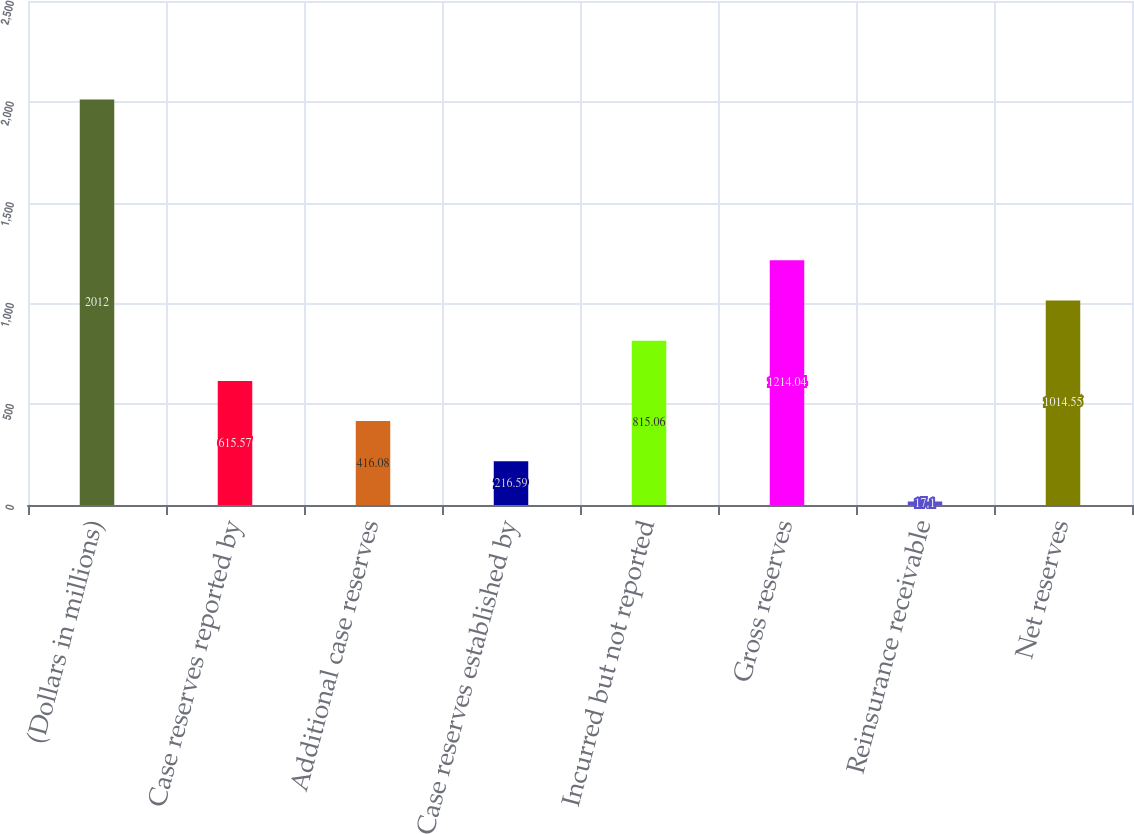Convert chart. <chart><loc_0><loc_0><loc_500><loc_500><bar_chart><fcel>(Dollars in millions)<fcel>Case reserves reported by<fcel>Additional case reserves<fcel>Case reserves established by<fcel>Incurred but not reported<fcel>Gross reserves<fcel>Reinsurance receivable<fcel>Net reserves<nl><fcel>2012<fcel>615.57<fcel>416.08<fcel>216.59<fcel>815.06<fcel>1214.04<fcel>17.1<fcel>1014.55<nl></chart> 